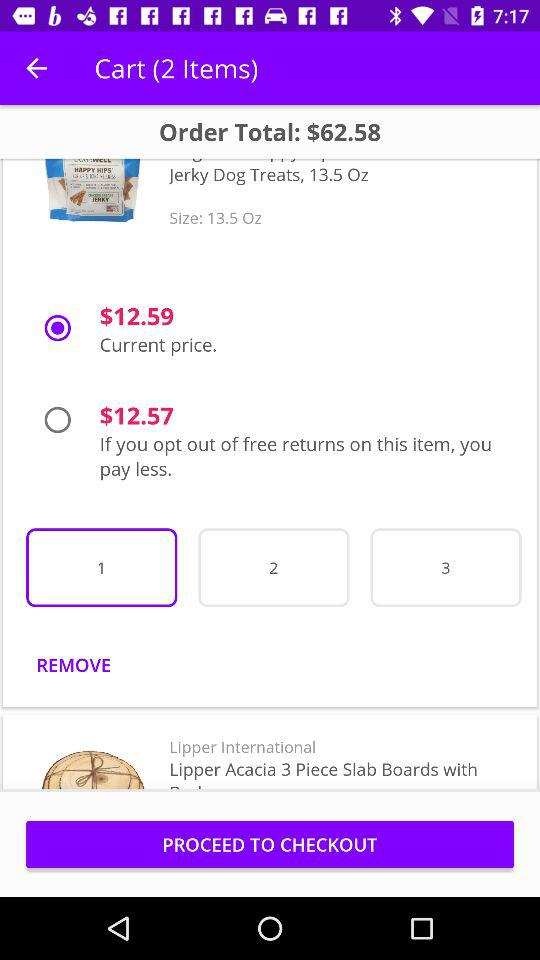How much money has to be paid for free returns on the item? For free returns on the item, $12.57 has to be paid. 